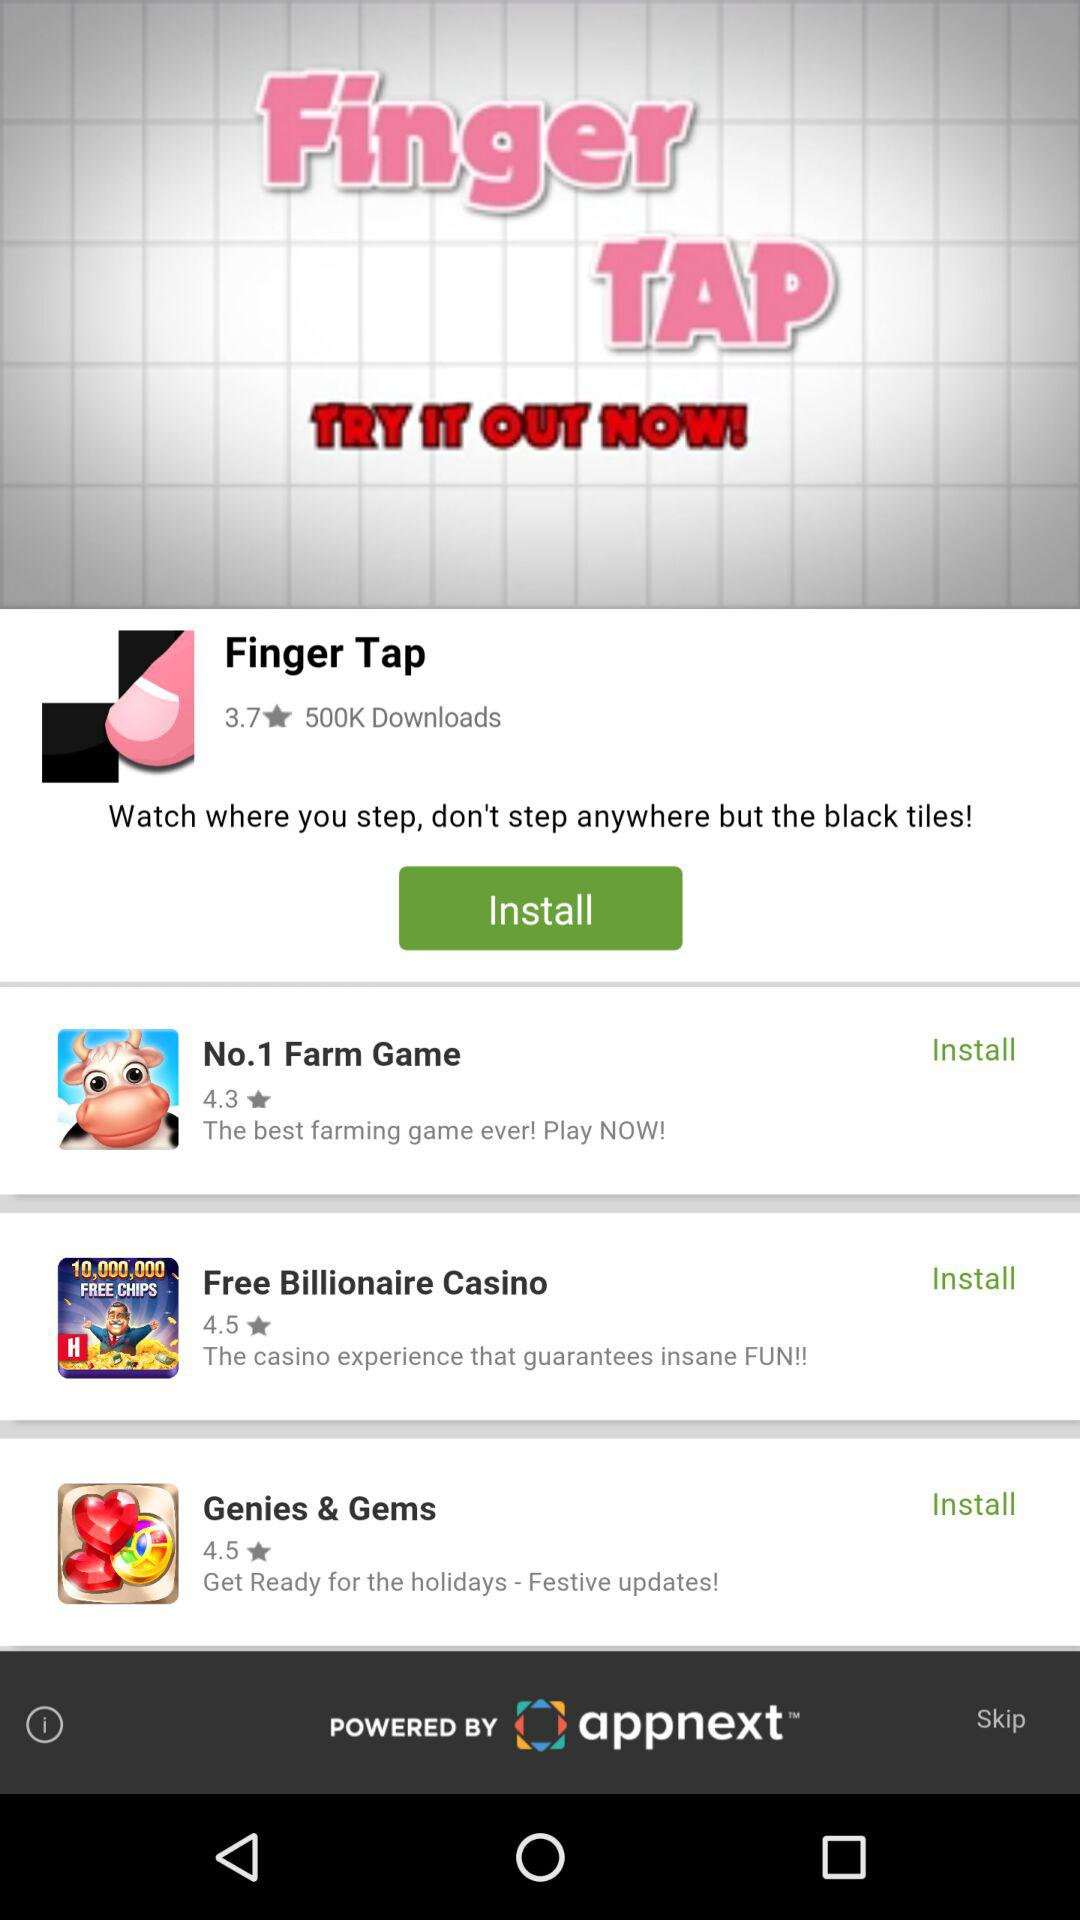What's the rating for "Genies & Gems"? The rating is 4.5. 